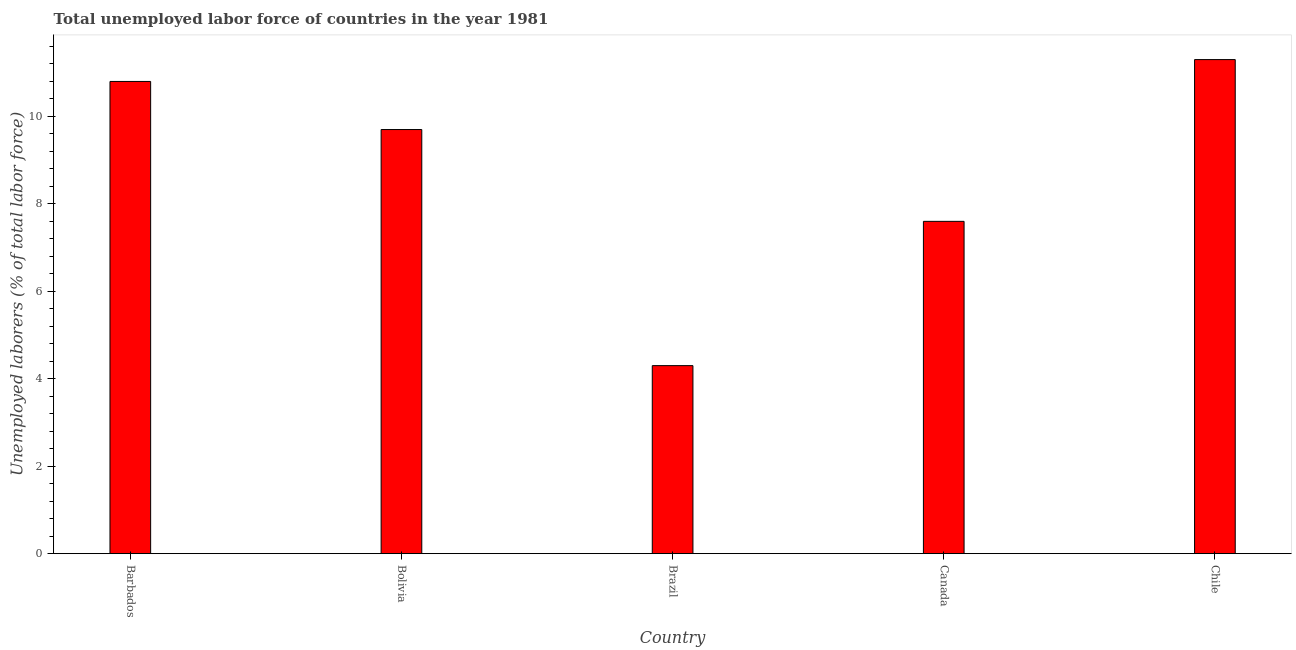Does the graph contain any zero values?
Your answer should be compact. No. What is the title of the graph?
Offer a terse response. Total unemployed labor force of countries in the year 1981. What is the label or title of the X-axis?
Give a very brief answer. Country. What is the label or title of the Y-axis?
Offer a terse response. Unemployed laborers (% of total labor force). What is the total unemployed labour force in Chile?
Offer a very short reply. 11.3. Across all countries, what is the maximum total unemployed labour force?
Ensure brevity in your answer.  11.3. Across all countries, what is the minimum total unemployed labour force?
Ensure brevity in your answer.  4.3. In which country was the total unemployed labour force maximum?
Your answer should be very brief. Chile. In which country was the total unemployed labour force minimum?
Offer a terse response. Brazil. What is the sum of the total unemployed labour force?
Keep it short and to the point. 43.7. What is the difference between the total unemployed labour force in Bolivia and Canada?
Keep it short and to the point. 2.1. What is the average total unemployed labour force per country?
Your response must be concise. 8.74. What is the median total unemployed labour force?
Offer a terse response. 9.7. What is the ratio of the total unemployed labour force in Bolivia to that in Brazil?
Provide a short and direct response. 2.26. Is the total unemployed labour force in Bolivia less than that in Brazil?
Offer a very short reply. No. Is the sum of the total unemployed labour force in Bolivia and Chile greater than the maximum total unemployed labour force across all countries?
Provide a short and direct response. Yes. What is the difference between the highest and the lowest total unemployed labour force?
Your response must be concise. 7. In how many countries, is the total unemployed labour force greater than the average total unemployed labour force taken over all countries?
Your answer should be very brief. 3. Are all the bars in the graph horizontal?
Provide a succinct answer. No. How many countries are there in the graph?
Offer a terse response. 5. What is the difference between two consecutive major ticks on the Y-axis?
Make the answer very short. 2. Are the values on the major ticks of Y-axis written in scientific E-notation?
Offer a terse response. No. What is the Unemployed laborers (% of total labor force) in Barbados?
Provide a succinct answer. 10.8. What is the Unemployed laborers (% of total labor force) of Bolivia?
Your answer should be very brief. 9.7. What is the Unemployed laborers (% of total labor force) in Brazil?
Provide a short and direct response. 4.3. What is the Unemployed laborers (% of total labor force) of Canada?
Offer a very short reply. 7.6. What is the Unemployed laborers (% of total labor force) in Chile?
Ensure brevity in your answer.  11.3. What is the difference between the Unemployed laborers (% of total labor force) in Barbados and Brazil?
Provide a succinct answer. 6.5. What is the difference between the Unemployed laborers (% of total labor force) in Barbados and Canada?
Offer a very short reply. 3.2. What is the difference between the Unemployed laborers (% of total labor force) in Barbados and Chile?
Give a very brief answer. -0.5. What is the difference between the Unemployed laborers (% of total labor force) in Bolivia and Canada?
Provide a succinct answer. 2.1. What is the ratio of the Unemployed laborers (% of total labor force) in Barbados to that in Bolivia?
Give a very brief answer. 1.11. What is the ratio of the Unemployed laborers (% of total labor force) in Barbados to that in Brazil?
Ensure brevity in your answer.  2.51. What is the ratio of the Unemployed laborers (% of total labor force) in Barbados to that in Canada?
Give a very brief answer. 1.42. What is the ratio of the Unemployed laborers (% of total labor force) in Barbados to that in Chile?
Offer a very short reply. 0.96. What is the ratio of the Unemployed laborers (% of total labor force) in Bolivia to that in Brazil?
Make the answer very short. 2.26. What is the ratio of the Unemployed laborers (% of total labor force) in Bolivia to that in Canada?
Offer a very short reply. 1.28. What is the ratio of the Unemployed laborers (% of total labor force) in Bolivia to that in Chile?
Your response must be concise. 0.86. What is the ratio of the Unemployed laborers (% of total labor force) in Brazil to that in Canada?
Your response must be concise. 0.57. What is the ratio of the Unemployed laborers (% of total labor force) in Brazil to that in Chile?
Offer a terse response. 0.38. What is the ratio of the Unemployed laborers (% of total labor force) in Canada to that in Chile?
Offer a terse response. 0.67. 